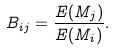Convert formula to latex. <formula><loc_0><loc_0><loc_500><loc_500>B _ { i j } = \frac { E ( M _ { j } ) } { E ( M _ { i } ) } .</formula> 